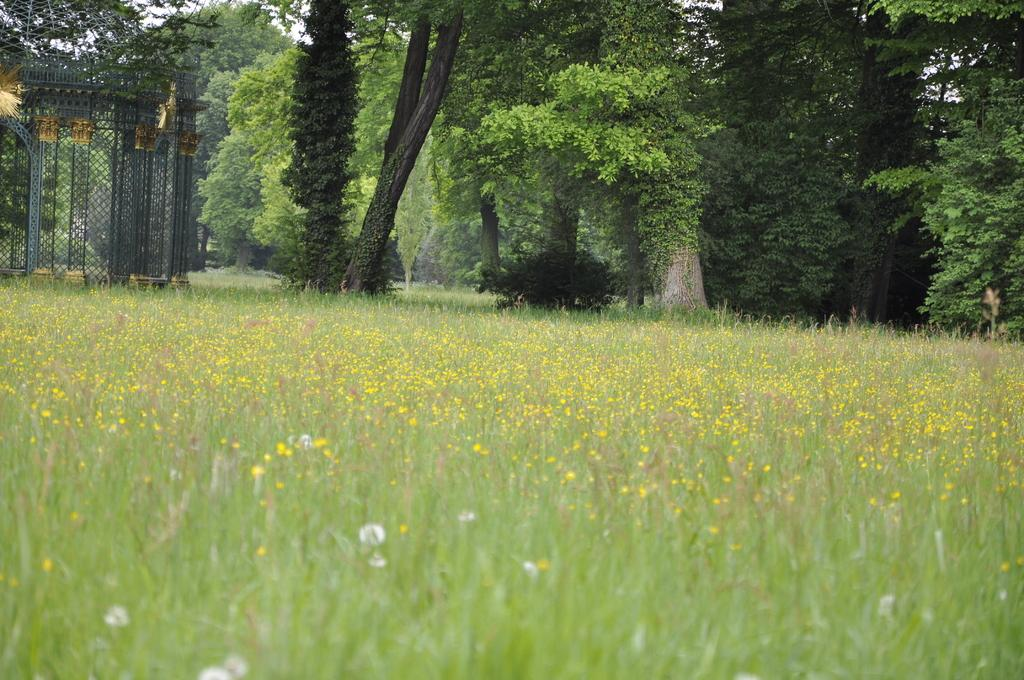What type of plants can be seen in the image? There are flowers, grass, and trees in the image. What is the ground covered with in the image? The ground is covered with grass in the image. What type of structures are present in the image? Metal rods are present in the image. What type of disease is affecting the flowers in the image? There is no indication of any disease affecting the flowers in the image. 